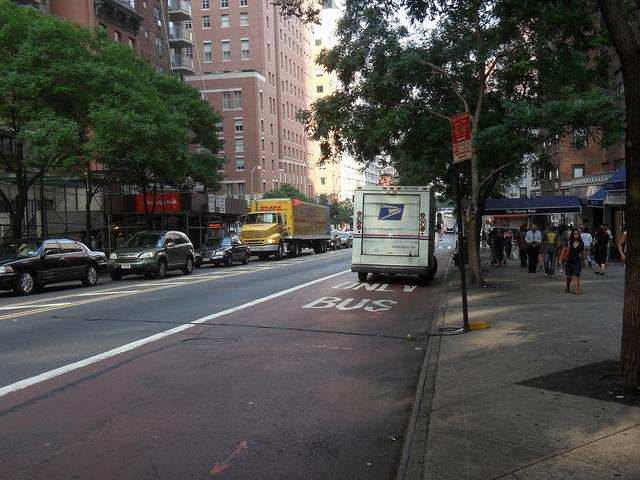What picture is on the truck?
Answer briefly. Eagle head. What color is the truck on the other side of the street?
Quick response, please. Yellow. What are the two words on the road?
Quick response, please. Only bus. What kind of vehicle is parked in the BUS ONLY lane?
Concise answer only. Mail truck. Are there more than one red sign in the photo?
Concise answer only. Yes. Will there be an accident?
Concise answer only. No. How many buses are pink?
Short answer required. 0. Is this photo taken in a forest?
Write a very short answer. No. What color is the delivery truck?
Concise answer only. Yellow. 